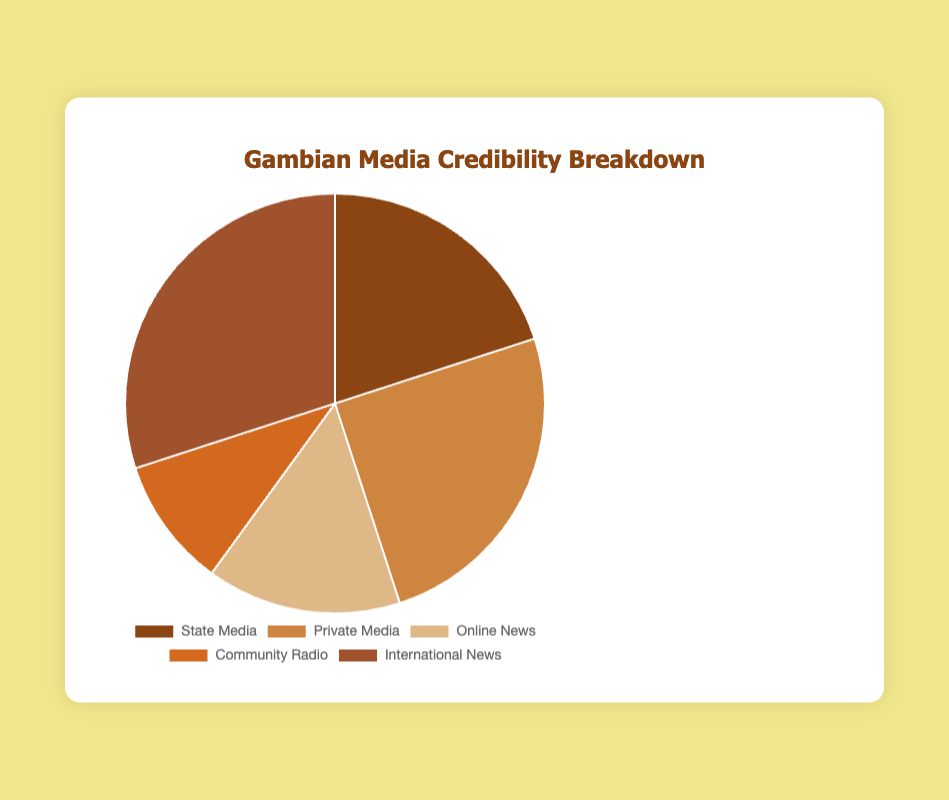What percentage of the media outlets is comprised of State Media and Private Media combined? State Media has 20% credibility, and Private Media has 25% credibility. Adding these together, 20% + 25% = 45%.
Answer: 45% Which media type has the highest credibility? International News has the highest credibility at 30%, which is the largest segment of the pie chart.
Answer: International News What is the difference in credibility between International News and Community Radio? International News has 30% credibility, and Community Radio has 10% credibility. The difference is 30% - 10% = 20%.
Answer: 20% What percentage of outlets falls under Online News and Community Radio together? Online News has 15% credibility and Community Radio has 10% credibility. Adding these together, 15% + 10% = 25%.
Answer: 25% Among the media types, which has the least credibility? Community Radio has the least credibility at 10%, which is the smallest segment of the pie chart.
Answer: Community Radio Is the credibility of Private Media greater than the combined credibility of Online News and Community Radio? Private Media has 25% credibility. The combined credibility of Online News and Community Radio is 15% + 10% = 25%. 25% is equal to 25%.
Answer: No Compare the credibility of State Media and Online News. Which one has more credibility and by how much? State Media has 20% credibility, and Online News has 15% credibility. State Media has more credibility by 20% - 15% = 5%.
Answer: State Media, by 5% What is the aggregated credibility of Community Radio, Online News, and State Media? Community Radio has 10% credibility, Online News has 15% credibility, and State Media has 20% credibility. Adding these together, 10% + 15% + 20% = 45%.
Answer: 45% What color is associated with the Private Media segment in the pie chart? The Private Media segment is represented with a brown color (#CD853F).
Answer: Brown 